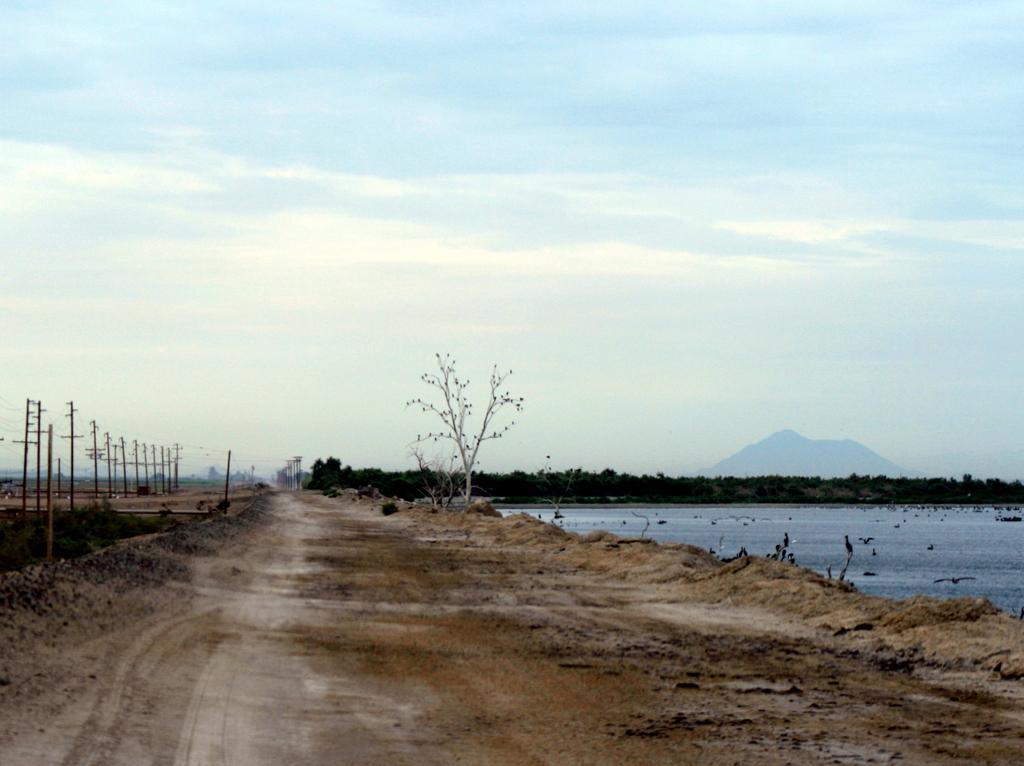How would you summarize this image in a sentence or two? In this image there is a path, beside the path there are a few utility poles and on the other side there are trees and river. In the background there is the sky. 